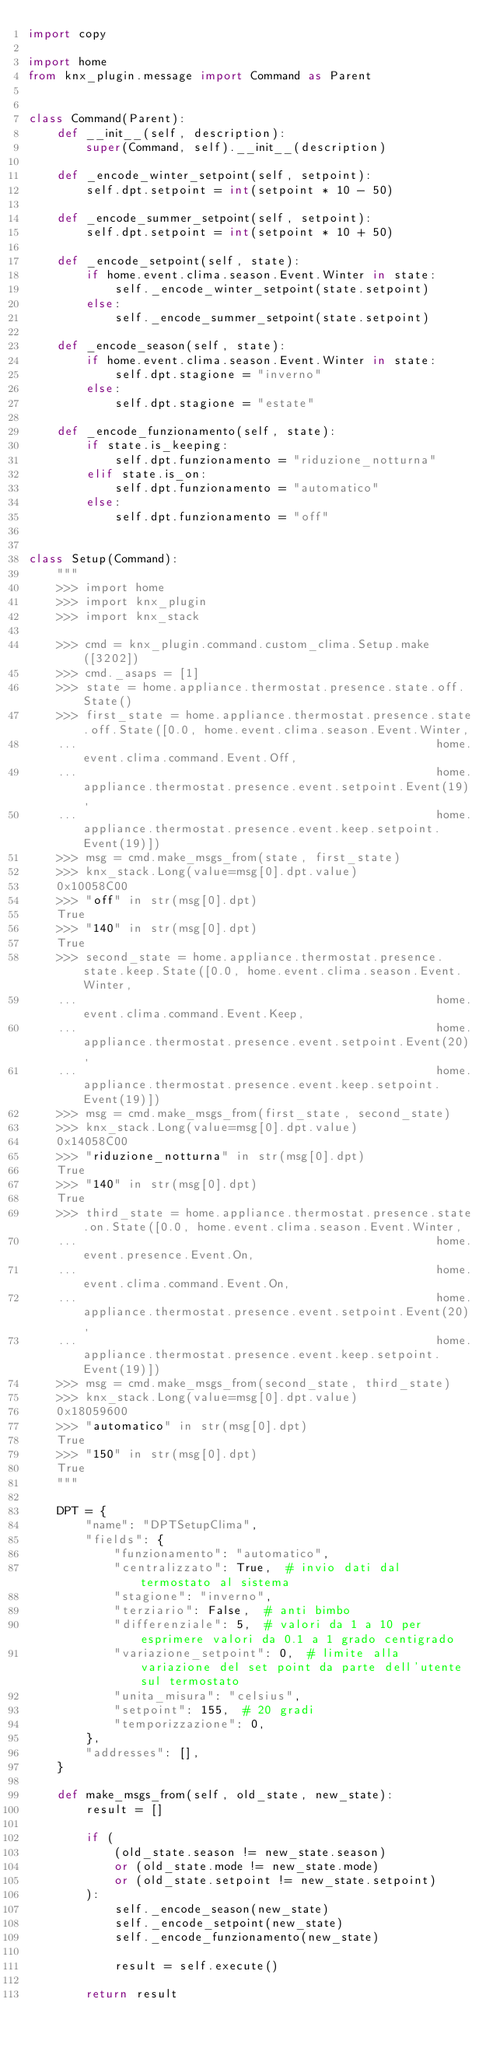<code> <loc_0><loc_0><loc_500><loc_500><_Python_>import copy

import home
from knx_plugin.message import Command as Parent


class Command(Parent):
    def __init__(self, description):
        super(Command, self).__init__(description)

    def _encode_winter_setpoint(self, setpoint):
        self.dpt.setpoint = int(setpoint * 10 - 50)

    def _encode_summer_setpoint(self, setpoint):
        self.dpt.setpoint = int(setpoint * 10 + 50)

    def _encode_setpoint(self, state):
        if home.event.clima.season.Event.Winter in state:
            self._encode_winter_setpoint(state.setpoint)
        else:
            self._encode_summer_setpoint(state.setpoint)

    def _encode_season(self, state):
        if home.event.clima.season.Event.Winter in state:
            self.dpt.stagione = "inverno"
        else:
            self.dpt.stagione = "estate"

    def _encode_funzionamento(self, state):
        if state.is_keeping:
            self.dpt.funzionamento = "riduzione_notturna"
        elif state.is_on:
            self.dpt.funzionamento = "automatico"
        else:
            self.dpt.funzionamento = "off"


class Setup(Command):
    """
    >>> import home
    >>> import knx_plugin
    >>> import knx_stack

    >>> cmd = knx_plugin.command.custom_clima.Setup.make([3202])
    >>> cmd._asaps = [1]
    >>> state = home.appliance.thermostat.presence.state.off.State()
    >>> first_state = home.appliance.thermostat.presence.state.off.State([0.0, home.event.clima.season.Event.Winter,
    ...                                                  home.event.clima.command.Event.Off,
    ...                                                  home.appliance.thermostat.presence.event.setpoint.Event(19),
    ...                                                  home.appliance.thermostat.presence.event.keep.setpoint.Event(19)])
    >>> msg = cmd.make_msgs_from(state, first_state)
    >>> knx_stack.Long(value=msg[0].dpt.value)
    0x10058C00
    >>> "off" in str(msg[0].dpt)
    True
    >>> "140" in str(msg[0].dpt)
    True
    >>> second_state = home.appliance.thermostat.presence.state.keep.State([0.0, home.event.clima.season.Event.Winter,
    ...                                                  home.event.clima.command.Event.Keep,
    ...                                                  home.appliance.thermostat.presence.event.setpoint.Event(20),
    ...                                                  home.appliance.thermostat.presence.event.keep.setpoint.Event(19)])
    >>> msg = cmd.make_msgs_from(first_state, second_state)
    >>> knx_stack.Long(value=msg[0].dpt.value)
    0x14058C00
    >>> "riduzione_notturna" in str(msg[0].dpt)
    True
    >>> "140" in str(msg[0].dpt)
    True
    >>> third_state = home.appliance.thermostat.presence.state.on.State([0.0, home.event.clima.season.Event.Winter,
    ...                                                  home.event.presence.Event.On,
    ...                                                  home.event.clima.command.Event.On,
    ...                                                  home.appliance.thermostat.presence.event.setpoint.Event(20),
    ...                                                  home.appliance.thermostat.presence.event.keep.setpoint.Event(19)])
    >>> msg = cmd.make_msgs_from(second_state, third_state)
    >>> knx_stack.Long(value=msg[0].dpt.value)
    0x18059600
    >>> "automatico" in str(msg[0].dpt)
    True
    >>> "150" in str(msg[0].dpt)
    True
    """

    DPT = {
        "name": "DPTSetupClima",
        "fields": {
            "funzionamento": "automatico",
            "centralizzato": True,  # invio dati dal termostato al sistema
            "stagione": "inverno",
            "terziario": False,  # anti bimbo
            "differenziale": 5,  # valori da 1 a 10 per esprimere valori da 0.1 a 1 grado centigrado
            "variazione_setpoint": 0,  # limite alla variazione del set point da parte dell'utente sul termostato
            "unita_misura": "celsius",
            "setpoint": 155,  # 20 gradi
            "temporizzazione": 0,
        },
        "addresses": [],
    }

    def make_msgs_from(self, old_state, new_state):
        result = []

        if (
            (old_state.season != new_state.season)
            or (old_state.mode != new_state.mode)
            or (old_state.setpoint != new_state.setpoint)
        ):
            self._encode_season(new_state)
            self._encode_setpoint(new_state)
            self._encode_funzionamento(new_state)

            result = self.execute()

        return result
</code> 